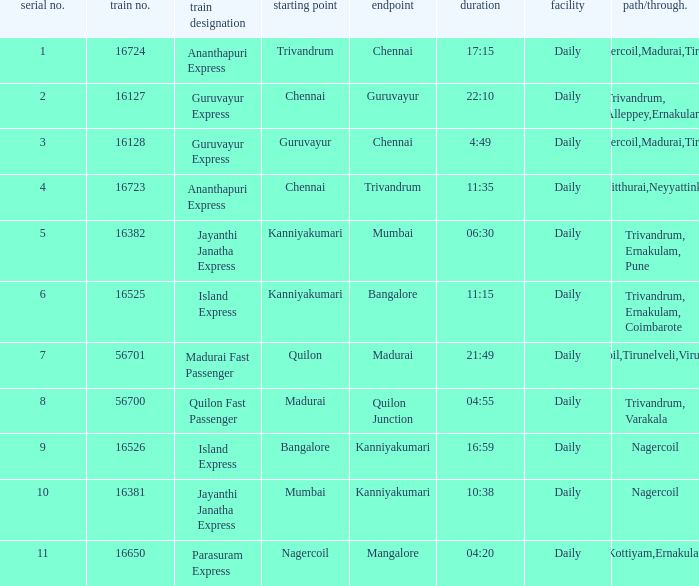What is the route/via when the train name is Parasuram Express? Trivandrum,Kottiyam,Ernakulam,Kozhikode. 